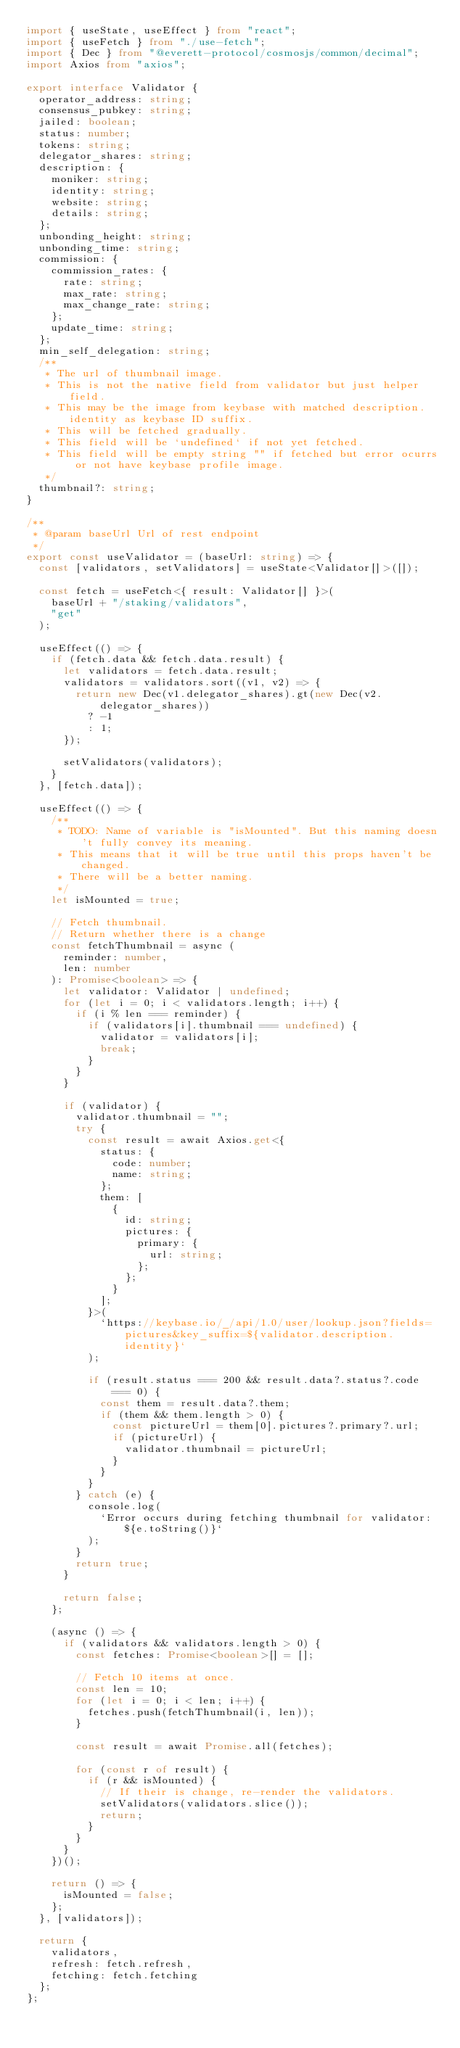Convert code to text. <code><loc_0><loc_0><loc_500><loc_500><_TypeScript_>import { useState, useEffect } from "react";
import { useFetch } from "./use-fetch";
import { Dec } from "@everett-protocol/cosmosjs/common/decimal";
import Axios from "axios";

export interface Validator {
  operator_address: string;
  consensus_pubkey: string;
  jailed: boolean;
  status: number;
  tokens: string;
  delegator_shares: string;
  description: {
    moniker: string;
    identity: string;
    website: string;
    details: string;
  };
  unbonding_height: string;
  unbonding_time: string;
  commission: {
    commission_rates: {
      rate: string;
      max_rate: string;
      max_change_rate: string;
    };
    update_time: string;
  };
  min_self_delegation: string;
  /**
   * The url of thumbnail image.
   * This is not the native field from validator but just helper field.
   * This may be the image from keybase with matched description.identity as keybase ID suffix.
   * This will be fetched gradually.
   * This field will be `undefined` if not yet fetched.
   * This field will be empty string "" if fetched but error ocurrs or not have keybase profile image.
   */
  thumbnail?: string;
}

/**
 * @param baseUrl Url of rest endpoint
 */
export const useValidator = (baseUrl: string) => {
  const [validators, setValidators] = useState<Validator[]>([]);

  const fetch = useFetch<{ result: Validator[] }>(
    baseUrl + "/staking/validators",
    "get"
  );

  useEffect(() => {
    if (fetch.data && fetch.data.result) {
      let validators = fetch.data.result;
      validators = validators.sort((v1, v2) => {
        return new Dec(v1.delegator_shares).gt(new Dec(v2.delegator_shares))
          ? -1
          : 1;
      });

      setValidators(validators);
    }
  }, [fetch.data]);

  useEffect(() => {
    /**
     * TODO: Name of variable is "isMounted". But this naming doesn't fully convey its meaning.
     * This means that it will be true until this props haven't be changed.
     * There will be a better naming.
     */
    let isMounted = true;

    // Fetch thumbnail.
    // Return whether there is a change
    const fetchThumbnail = async (
      reminder: number,
      len: number
    ): Promise<boolean> => {
      let validator: Validator | undefined;
      for (let i = 0; i < validators.length; i++) {
        if (i % len === reminder) {
          if (validators[i].thumbnail === undefined) {
            validator = validators[i];
            break;
          }
        }
      }

      if (validator) {
        validator.thumbnail = "";
        try {
          const result = await Axios.get<{
            status: {
              code: number;
              name: string;
            };
            them: [
              {
                id: string;
                pictures: {
                  primary: {
                    url: string;
                  };
                };
              }
            ];
          }>(
            `https://keybase.io/_/api/1.0/user/lookup.json?fields=pictures&key_suffix=${validator.description.identity}`
          );

          if (result.status === 200 && result.data?.status?.code === 0) {
            const them = result.data?.them;
            if (them && them.length > 0) {
              const pictureUrl = them[0].pictures?.primary?.url;
              if (pictureUrl) {
                validator.thumbnail = pictureUrl;
              }
            }
          }
        } catch (e) {
          console.log(
            `Error occurs during fetching thumbnail for validator: ${e.toString()}`
          );
        }
        return true;
      }

      return false;
    };

    (async () => {
      if (validators && validators.length > 0) {
        const fetches: Promise<boolean>[] = [];

        // Fetch 10 items at once.
        const len = 10;
        for (let i = 0; i < len; i++) {
          fetches.push(fetchThumbnail(i, len));
        }

        const result = await Promise.all(fetches);

        for (const r of result) {
          if (r && isMounted) {
            // If their is change, re-render the validators.
            setValidators(validators.slice());
            return;
          }
        }
      }
    })();

    return () => {
      isMounted = false;
    };
  }, [validators]);

  return {
    validators,
    refresh: fetch.refresh,
    fetching: fetch.fetching
  };
};
</code> 